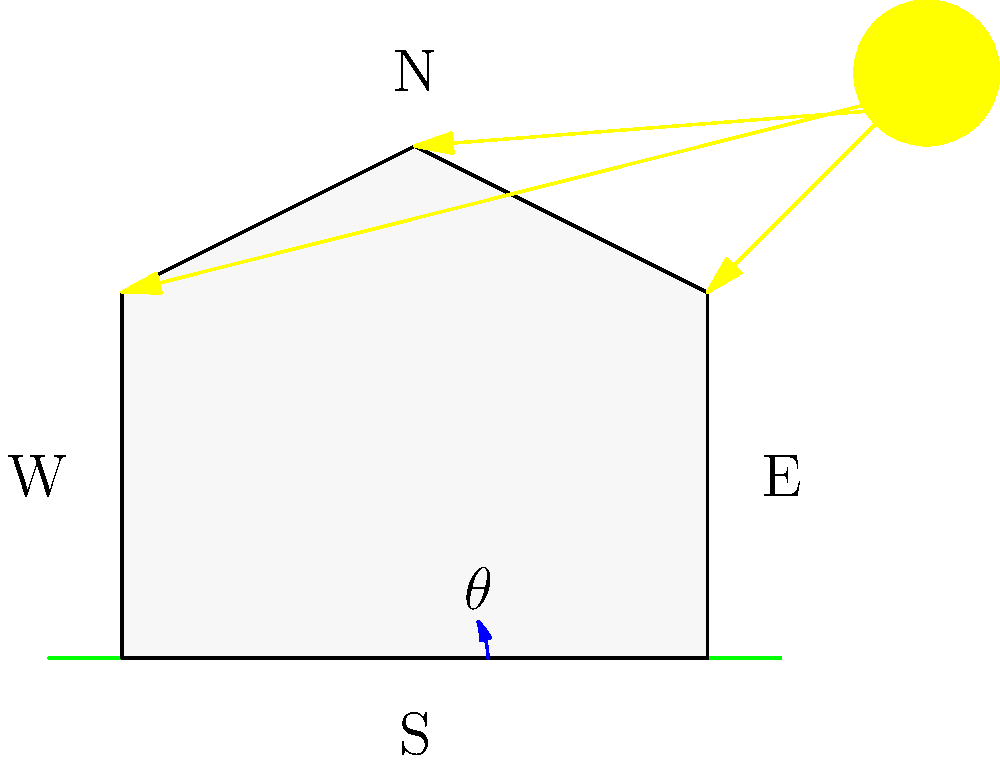In designing an energy-efficient greenhouse for long-term GMO studies, you need to optimize its orientation for maximum light exposure. Given that the greenhouse is located in the Northern Hemisphere, what is the optimal angle $\theta$ (in degrees) between the greenhouse's long axis and the east-west line to maximize year-round solar exposure? To determine the optimal angle for the greenhouse orientation, we need to consider several factors:

1. The greenhouse is in the Northern Hemisphere, where the sun's path is predominantly in the southern sky.

2. We want to maximize year-round solar exposure, not just for a specific season.

3. The sun's position changes throughout the year, being higher in the summer and lower in the winter.

4. The optimal angle should balance morning and afternoon sun exposure while minimizing overheating during peak summer hours.

5. Research has shown that orienting the greenhouse's long axis east-west with a slight tilt towards the south-east provides the best year-round performance.

6. This slight tilt helps capture more morning sun (which is beneficial for plant growth) and reduces overheating in the afternoon.

7. Studies and practical experience in greenhouse design have found that an angle of about 20-25 degrees from the east-west line provides the best balance.

8. For our specific question, we'll use the middle of this range: 22.5 degrees.

Therefore, the optimal angle $\theta$ between the greenhouse's long axis and the east-west line is approximately 22.5 degrees, with the southern end of the greenhouse tilted towards the east.
Answer: $22.5^\circ$ 